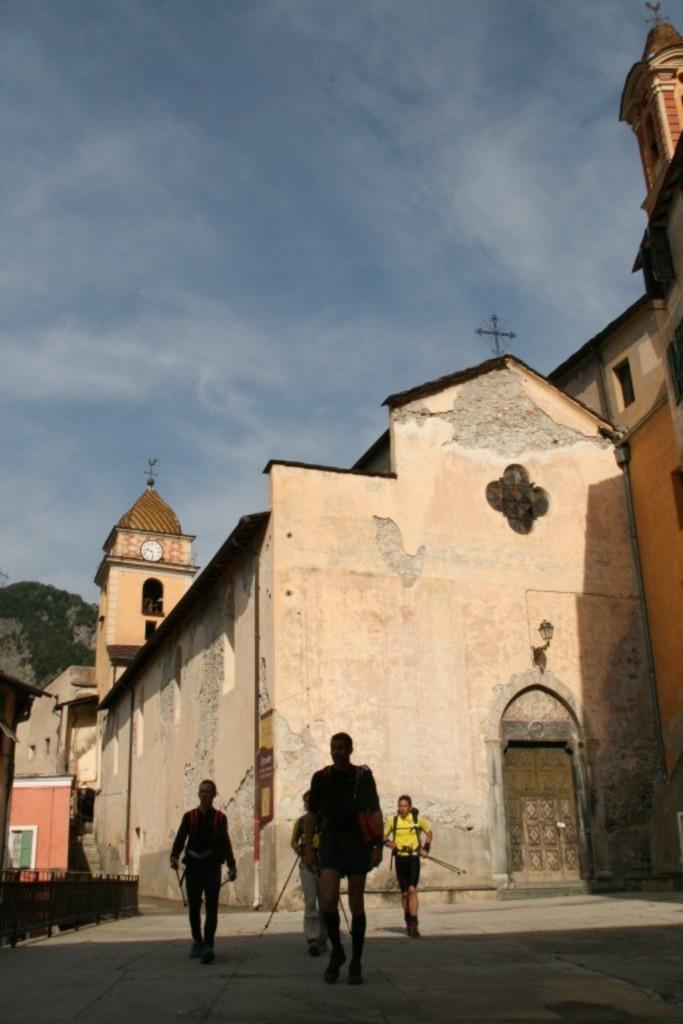Can you describe this image briefly? This picture is clicked outside. In the foreground we can see the group of persons walking on the ground. In the center we can see the buildings and a clock hanging on the wall of a spire. In the background we can see the sky and an object seems to be the hill. 